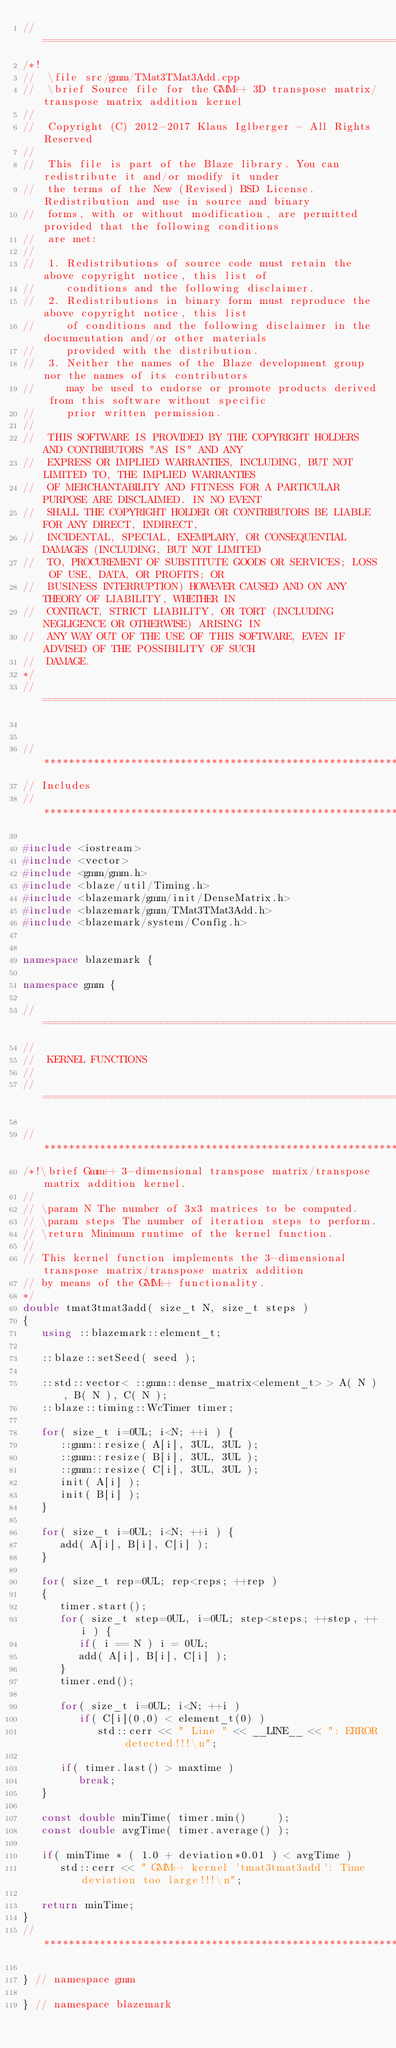Convert code to text. <code><loc_0><loc_0><loc_500><loc_500><_C++_>//=================================================================================================
/*!
//  \file src/gmm/TMat3TMat3Add.cpp
//  \brief Source file for the GMM++ 3D transpose matrix/transpose matrix addition kernel
//
//  Copyright (C) 2012-2017 Klaus Iglberger - All Rights Reserved
//
//  This file is part of the Blaze library. You can redistribute it and/or modify it under
//  the terms of the New (Revised) BSD License. Redistribution and use in source and binary
//  forms, with or without modification, are permitted provided that the following conditions
//  are met:
//
//  1. Redistributions of source code must retain the above copyright notice, this list of
//     conditions and the following disclaimer.
//  2. Redistributions in binary form must reproduce the above copyright notice, this list
//     of conditions and the following disclaimer in the documentation and/or other materials
//     provided with the distribution.
//  3. Neither the names of the Blaze development group nor the names of its contributors
//     may be used to endorse or promote products derived from this software without specific
//     prior written permission.
//
//  THIS SOFTWARE IS PROVIDED BY THE COPYRIGHT HOLDERS AND CONTRIBUTORS "AS IS" AND ANY
//  EXPRESS OR IMPLIED WARRANTIES, INCLUDING, BUT NOT LIMITED TO, THE IMPLIED WARRANTIES
//  OF MERCHANTABILITY AND FITNESS FOR A PARTICULAR PURPOSE ARE DISCLAIMED. IN NO EVENT
//  SHALL THE COPYRIGHT HOLDER OR CONTRIBUTORS BE LIABLE FOR ANY DIRECT, INDIRECT,
//  INCIDENTAL, SPECIAL, EXEMPLARY, OR CONSEQUENTIAL DAMAGES (INCLUDING, BUT NOT LIMITED
//  TO, PROCUREMENT OF SUBSTITUTE GOODS OR SERVICES; LOSS OF USE, DATA, OR PROFITS; OR
//  BUSINESS INTERRUPTION) HOWEVER CAUSED AND ON ANY THEORY OF LIABILITY, WHETHER IN
//  CONTRACT, STRICT LIABILITY, OR TORT (INCLUDING NEGLIGENCE OR OTHERWISE) ARISING IN
//  ANY WAY OUT OF THE USE OF THIS SOFTWARE, EVEN IF ADVISED OF THE POSSIBILITY OF SUCH
//  DAMAGE.
*/
//=================================================================================================


//*************************************************************************************************
// Includes
//*************************************************************************************************

#include <iostream>
#include <vector>
#include <gmm/gmm.h>
#include <blaze/util/Timing.h>
#include <blazemark/gmm/init/DenseMatrix.h>
#include <blazemark/gmm/TMat3TMat3Add.h>
#include <blazemark/system/Config.h>


namespace blazemark {

namespace gmm {

//=================================================================================================
//
//  KERNEL FUNCTIONS
//
//=================================================================================================

//*************************************************************************************************
/*!\brief Gmm++ 3-dimensional transpose matrix/transpose matrix addition kernel.
//
// \param N The number of 3x3 matrices to be computed.
// \param steps The number of iteration steps to perform.
// \return Minimum runtime of the kernel function.
//
// This kernel function implements the 3-dimensional transpose matrix/transpose matrix addition
// by means of the GMM++ functionality.
*/
double tmat3tmat3add( size_t N, size_t steps )
{
   using ::blazemark::element_t;

   ::blaze::setSeed( seed );

   ::std::vector< ::gmm::dense_matrix<element_t> > A( N ), B( N ), C( N );
   ::blaze::timing::WcTimer timer;

   for( size_t i=0UL; i<N; ++i ) {
      ::gmm::resize( A[i], 3UL, 3UL );
      ::gmm::resize( B[i], 3UL, 3UL );
      ::gmm::resize( C[i], 3UL, 3UL );
      init( A[i] );
      init( B[i] );
   }

   for( size_t i=0UL; i<N; ++i ) {
      add( A[i], B[i], C[i] );
   }

   for( size_t rep=0UL; rep<reps; ++rep )
   {
      timer.start();
      for( size_t step=0UL, i=0UL; step<steps; ++step, ++i ) {
         if( i == N ) i = 0UL;
         add( A[i], B[i], C[i] );
      }
      timer.end();

      for( size_t i=0UL; i<N; ++i )
         if( C[i](0,0) < element_t(0) )
            std::cerr << " Line " << __LINE__ << ": ERROR detected!!!\n";

      if( timer.last() > maxtime )
         break;
   }

   const double minTime( timer.min()     );
   const double avgTime( timer.average() );

   if( minTime * ( 1.0 + deviation*0.01 ) < avgTime )
      std::cerr << " GMM++ kernel 'tmat3tmat3add': Time deviation too large!!!\n";

   return minTime;
}
//*************************************************************************************************

} // namespace gmm

} // namespace blazemark
</code> 